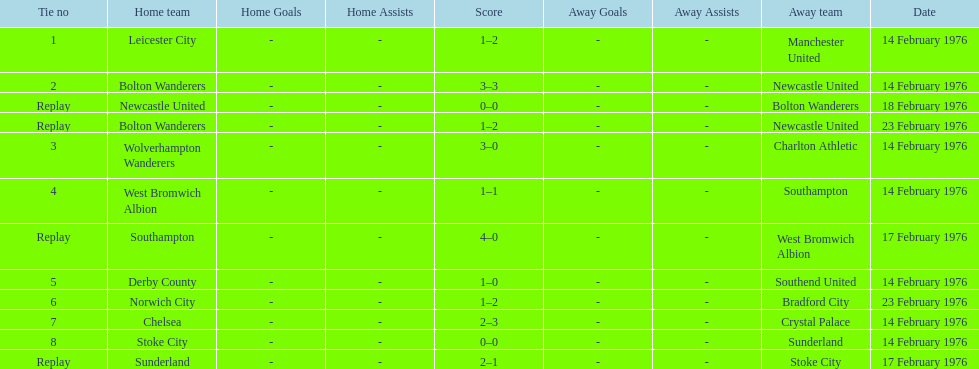Who had a better score, manchester united or wolverhampton wanderers? Wolverhampton Wanderers. 